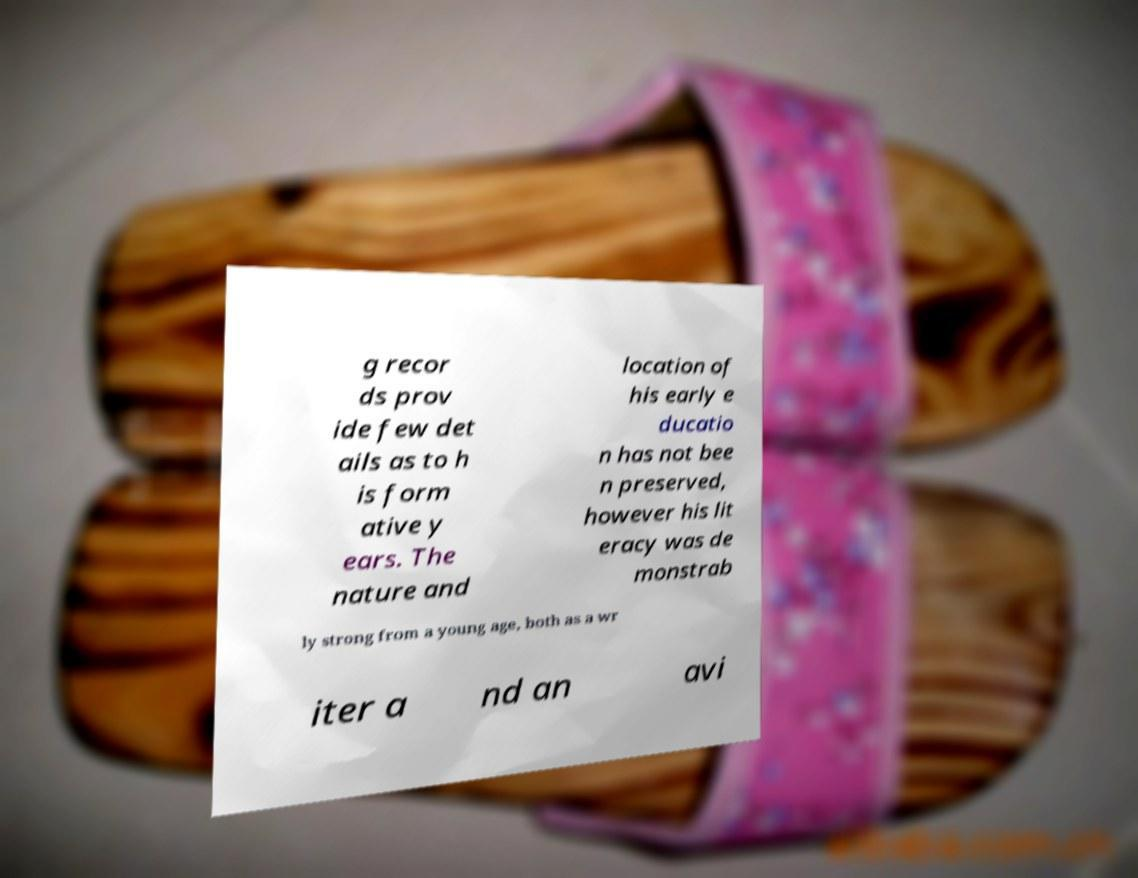Can you accurately transcribe the text from the provided image for me? g recor ds prov ide few det ails as to h is form ative y ears. The nature and location of his early e ducatio n has not bee n preserved, however his lit eracy was de monstrab ly strong from a young age, both as a wr iter a nd an avi 